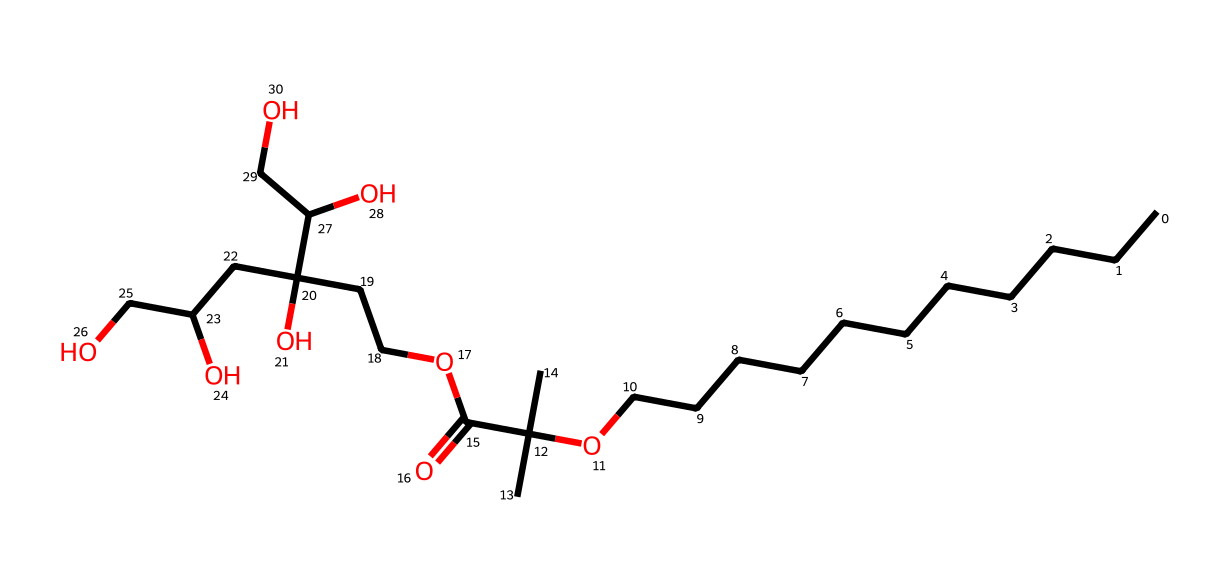what is the molecular formula of this compound? To find the molecular formula, we need to count the different atoms present in the SMILES representation. By parsing it, we find there are 20 carbon (C) atoms, 42 hydrogen (H) atoms, and 6 oxygen (O) atoms. This gives the formula C20H42O6.
Answer: C20H42O6 how many hydroxyl groups are present in the structure? Hydroxyl groups have the –OH functional group. By examining the chemical structure represented by the SMILES, we can see that there are 5 hydroxyl (–OH) groups attached to the carbon chains.
Answer: 5 what type of surfactant is represented by this chemical? Nonionic surfactants are characterized by the absence of a charge in their structure, typically containing large hydrophobic carbon chains and hydrophilic groups. The molecule shown, with its long carbon chain and several hydroxyl groups, indicates it is a nonionic surfactant.
Answer: nonionic what is the significance of the carbon chain length in detergents? The carbon chain length is crucial in determining the hydrophobicity of the detergent. Longer chains generally increase the hydrophobic character, enhancing the detergent's cleaning ability, making it more effective in emulsifying oils and greases. In this molecule, the long carbon chain contributes to its effectiveness.
Answer: hydrophobicity how does the presence of multiple functional groups affect the solubility of this detergent? The presence of multiple hydroxyl groups increases the polarity of the molecule, which enhances its solubility in water. The combination of hydrophobic carbon chains and hydrophilic hydroxyl groups allows this detergent to dissolve in both water and oils, making it effective in cleaning applications.
Answer: enhances solubility 